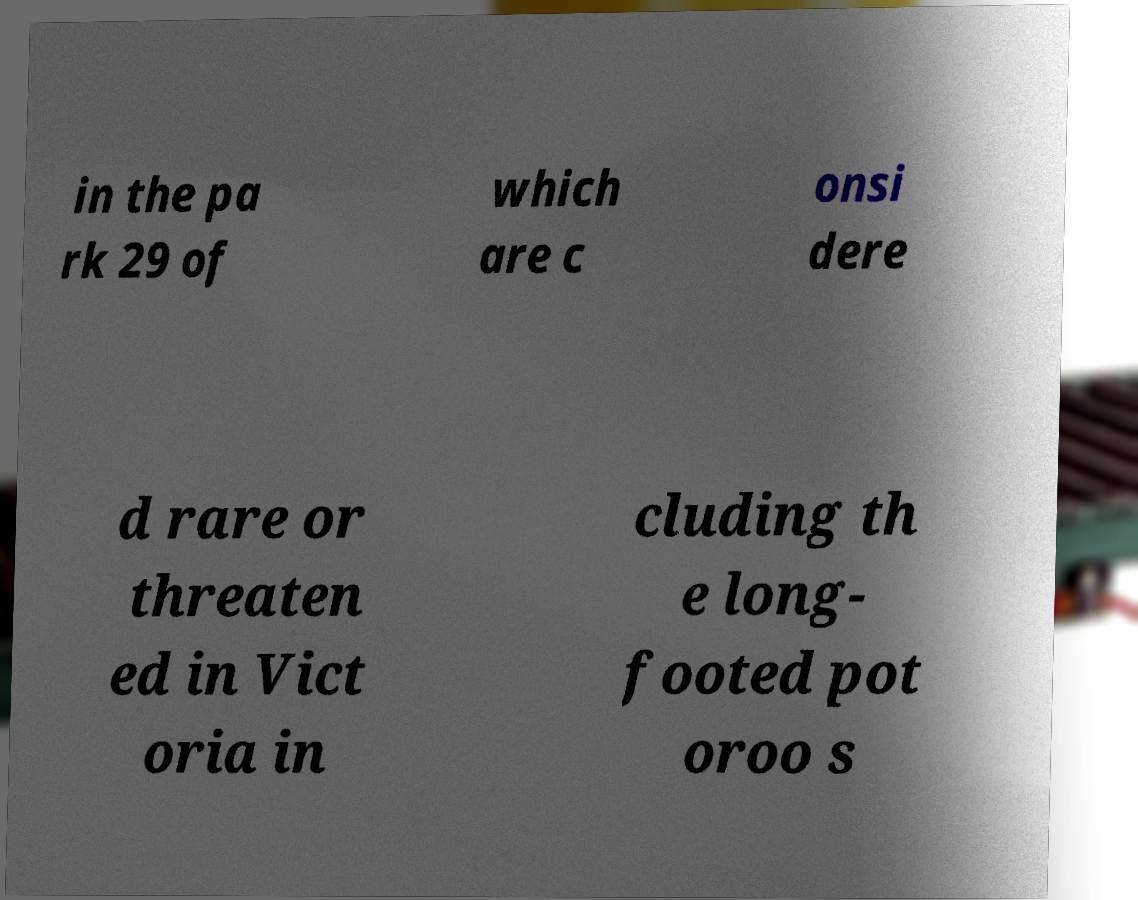Please read and relay the text visible in this image. What does it say? in the pa rk 29 of which are c onsi dere d rare or threaten ed in Vict oria in cluding th e long- footed pot oroo s 